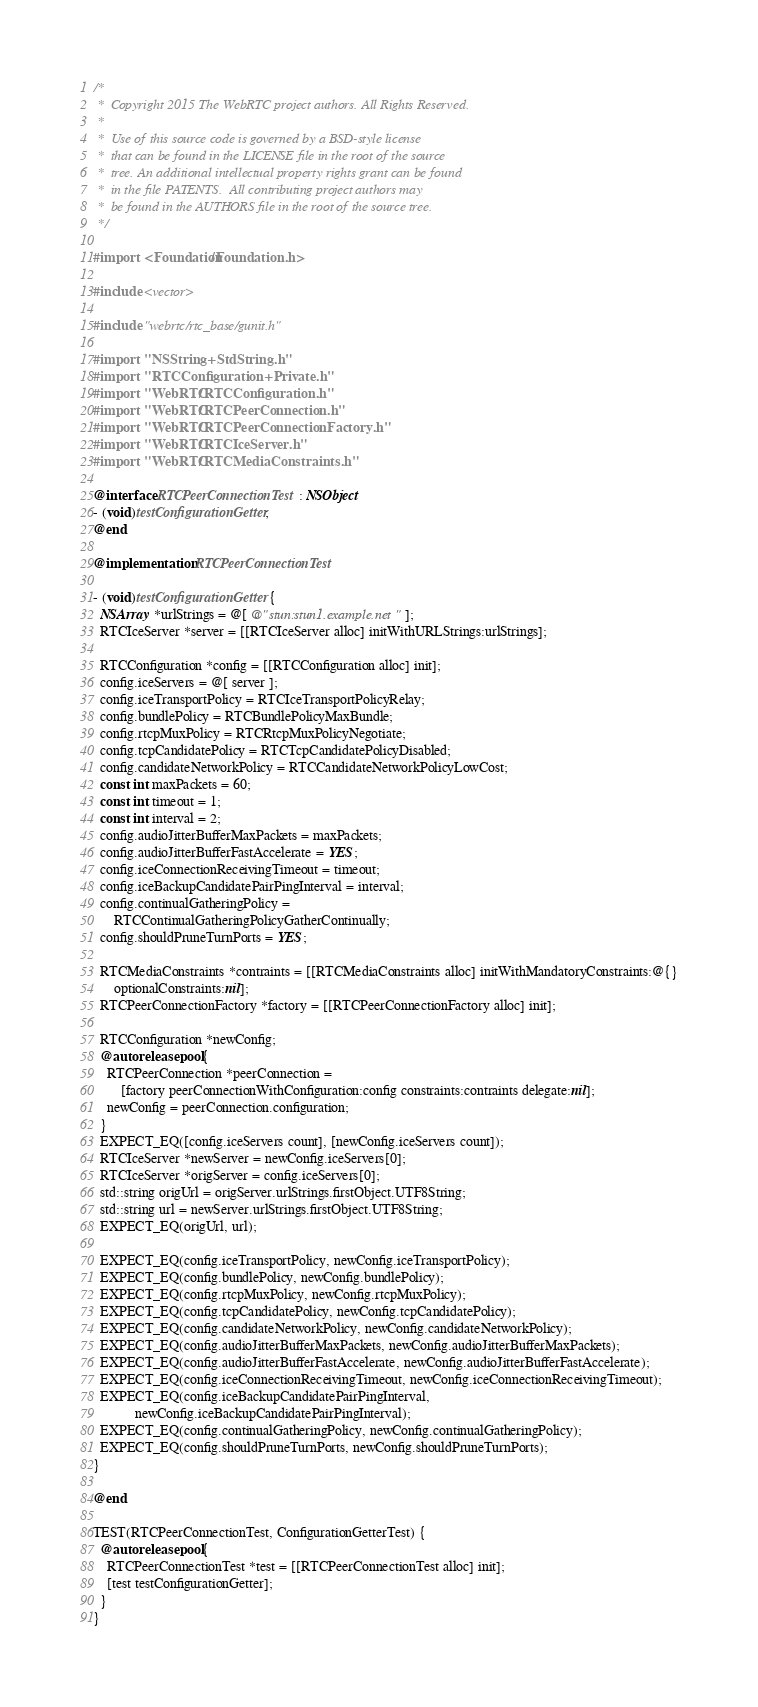Convert code to text. <code><loc_0><loc_0><loc_500><loc_500><_ObjectiveC_>/*
 *  Copyright 2015 The WebRTC project authors. All Rights Reserved.
 *
 *  Use of this source code is governed by a BSD-style license
 *  that can be found in the LICENSE file in the root of the source
 *  tree. An additional intellectual property rights grant can be found
 *  in the file PATENTS.  All contributing project authors may
 *  be found in the AUTHORS file in the root of the source tree.
 */

#import <Foundation/Foundation.h>

#include <vector>

#include "webrtc/rtc_base/gunit.h"

#import "NSString+StdString.h"
#import "RTCConfiguration+Private.h"
#import "WebRTC/RTCConfiguration.h"
#import "WebRTC/RTCPeerConnection.h"
#import "WebRTC/RTCPeerConnectionFactory.h"
#import "WebRTC/RTCIceServer.h"
#import "WebRTC/RTCMediaConstraints.h"

@interface RTCPeerConnectionTest : NSObject
- (void)testConfigurationGetter;
@end

@implementation RTCPeerConnectionTest

- (void)testConfigurationGetter {
  NSArray *urlStrings = @[ @"stun:stun1.example.net" ];
  RTCIceServer *server = [[RTCIceServer alloc] initWithURLStrings:urlStrings];

  RTCConfiguration *config = [[RTCConfiguration alloc] init];
  config.iceServers = @[ server ];
  config.iceTransportPolicy = RTCIceTransportPolicyRelay;
  config.bundlePolicy = RTCBundlePolicyMaxBundle;
  config.rtcpMuxPolicy = RTCRtcpMuxPolicyNegotiate;
  config.tcpCandidatePolicy = RTCTcpCandidatePolicyDisabled;
  config.candidateNetworkPolicy = RTCCandidateNetworkPolicyLowCost;
  const int maxPackets = 60;
  const int timeout = 1;
  const int interval = 2;
  config.audioJitterBufferMaxPackets = maxPackets;
  config.audioJitterBufferFastAccelerate = YES;
  config.iceConnectionReceivingTimeout = timeout;
  config.iceBackupCandidatePairPingInterval = interval;
  config.continualGatheringPolicy =
      RTCContinualGatheringPolicyGatherContinually;
  config.shouldPruneTurnPorts = YES;

  RTCMediaConstraints *contraints = [[RTCMediaConstraints alloc] initWithMandatoryConstraints:@{}
      optionalConstraints:nil];
  RTCPeerConnectionFactory *factory = [[RTCPeerConnectionFactory alloc] init];

  RTCConfiguration *newConfig;
  @autoreleasepool {
    RTCPeerConnection *peerConnection =
        [factory peerConnectionWithConfiguration:config constraints:contraints delegate:nil];
    newConfig = peerConnection.configuration;
  }
  EXPECT_EQ([config.iceServers count], [newConfig.iceServers count]);
  RTCIceServer *newServer = newConfig.iceServers[0];
  RTCIceServer *origServer = config.iceServers[0];
  std::string origUrl = origServer.urlStrings.firstObject.UTF8String;
  std::string url = newServer.urlStrings.firstObject.UTF8String;
  EXPECT_EQ(origUrl, url);

  EXPECT_EQ(config.iceTransportPolicy, newConfig.iceTransportPolicy);
  EXPECT_EQ(config.bundlePolicy, newConfig.bundlePolicy);
  EXPECT_EQ(config.rtcpMuxPolicy, newConfig.rtcpMuxPolicy);
  EXPECT_EQ(config.tcpCandidatePolicy, newConfig.tcpCandidatePolicy);
  EXPECT_EQ(config.candidateNetworkPolicy, newConfig.candidateNetworkPolicy);
  EXPECT_EQ(config.audioJitterBufferMaxPackets, newConfig.audioJitterBufferMaxPackets);
  EXPECT_EQ(config.audioJitterBufferFastAccelerate, newConfig.audioJitterBufferFastAccelerate);
  EXPECT_EQ(config.iceConnectionReceivingTimeout, newConfig.iceConnectionReceivingTimeout);
  EXPECT_EQ(config.iceBackupCandidatePairPingInterval,
            newConfig.iceBackupCandidatePairPingInterval);
  EXPECT_EQ(config.continualGatheringPolicy, newConfig.continualGatheringPolicy);
  EXPECT_EQ(config.shouldPruneTurnPorts, newConfig.shouldPruneTurnPorts);
}

@end

TEST(RTCPeerConnectionTest, ConfigurationGetterTest) {
  @autoreleasepool {
    RTCPeerConnectionTest *test = [[RTCPeerConnectionTest alloc] init];
    [test testConfigurationGetter];
  }
}


</code> 